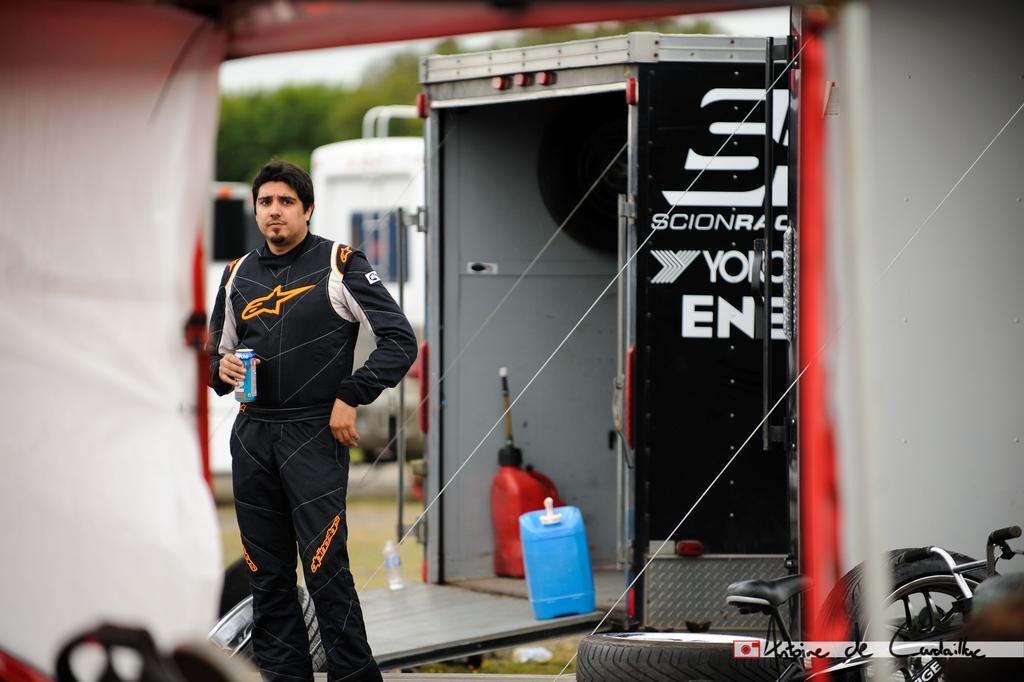What is the person in the image doing? The person is standing in the image and holding a beverage in their hands. What can be seen in the background of the image? There are bicycles, trees, pipelines, and the sky visible in the background of the image. What type of chess game is being played in the image? There is no chess game present in the image. What government policies are being discussed in the image? There is no discussion of government policies in the image. 